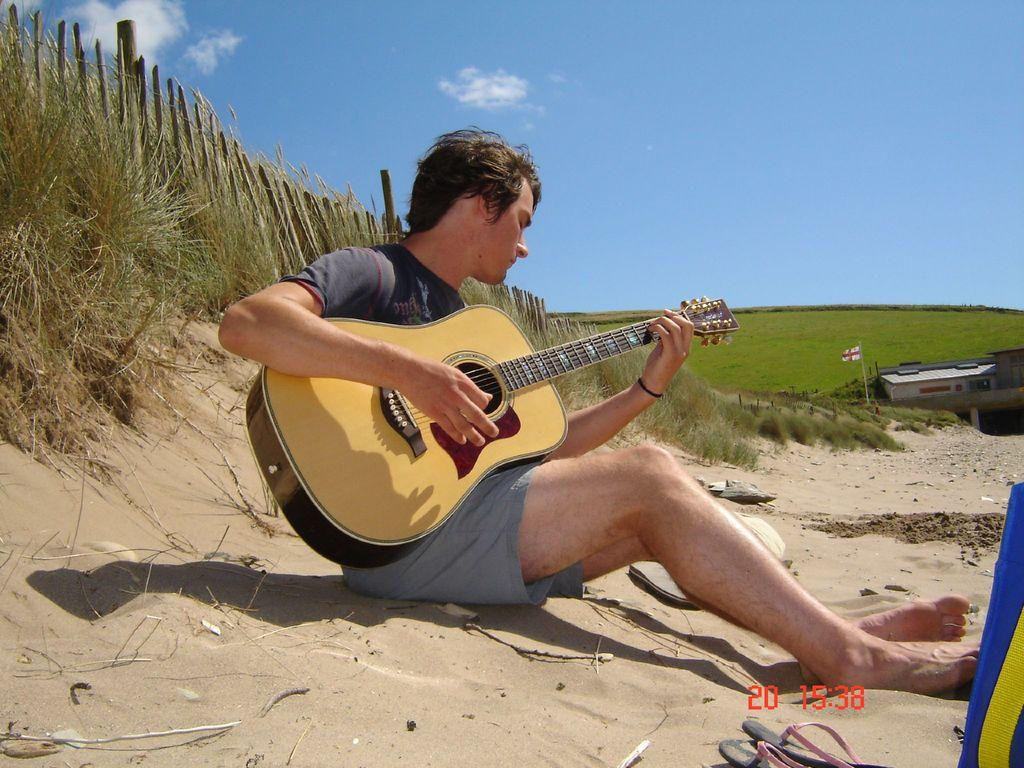What is the man in the image doing? The man is seated on the sand and playing a guitar. What can be seen in the background of the image? There is a wooden fence and plants visible in the background. What is the condition of the sky in the image? The sky is blue and cloudy. What other object can be seen in the image? There is a flag in the image. How does the man push the horse in the image? There is no horse present in the image, so the man cannot push a horse. 